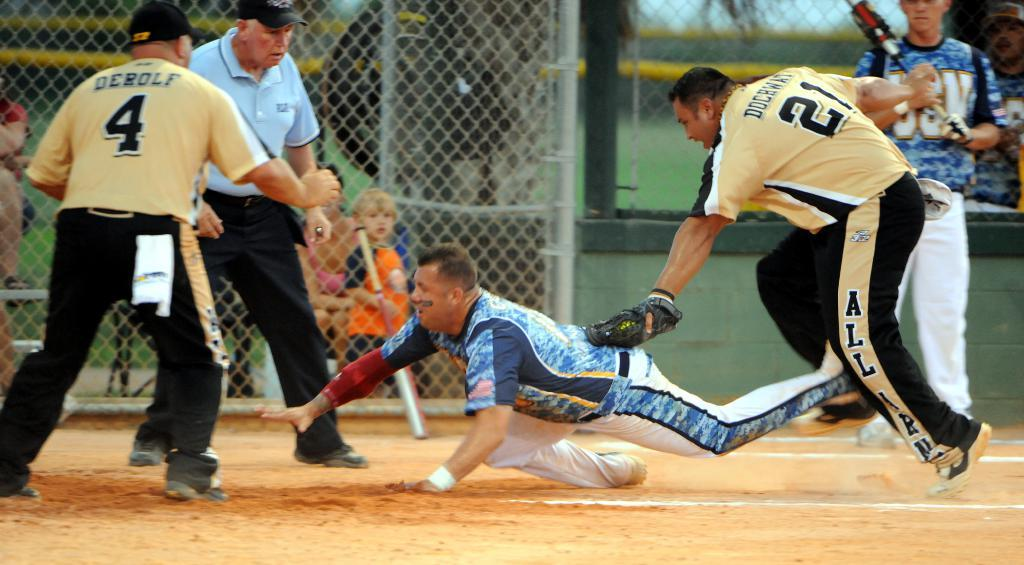<image>
Share a concise interpretation of the image provided. A guy named DEROLF wearing a shirt with the number 4 on it. 